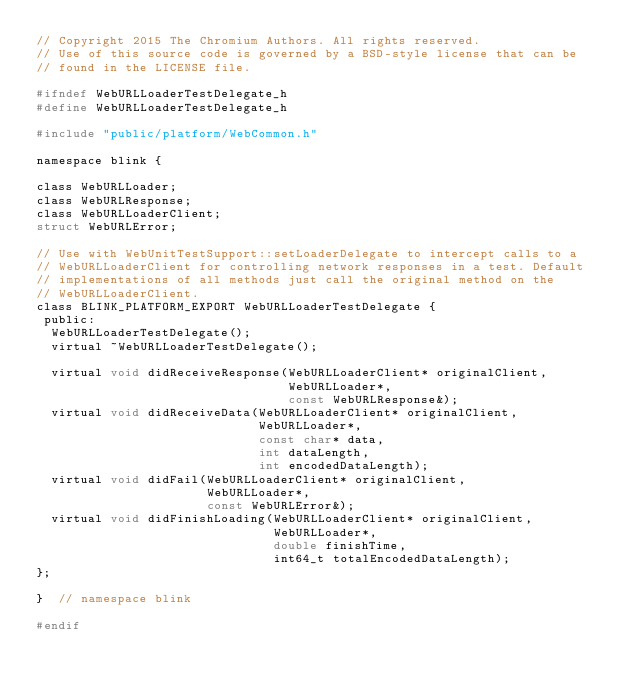Convert code to text. <code><loc_0><loc_0><loc_500><loc_500><_C_>// Copyright 2015 The Chromium Authors. All rights reserved.
// Use of this source code is governed by a BSD-style license that can be
// found in the LICENSE file.

#ifndef WebURLLoaderTestDelegate_h
#define WebURLLoaderTestDelegate_h

#include "public/platform/WebCommon.h"

namespace blink {

class WebURLLoader;
class WebURLResponse;
class WebURLLoaderClient;
struct WebURLError;

// Use with WebUnitTestSupport::setLoaderDelegate to intercept calls to a
// WebURLLoaderClient for controlling network responses in a test. Default
// implementations of all methods just call the original method on the
// WebURLLoaderClient.
class BLINK_PLATFORM_EXPORT WebURLLoaderTestDelegate {
 public:
  WebURLLoaderTestDelegate();
  virtual ~WebURLLoaderTestDelegate();

  virtual void didReceiveResponse(WebURLLoaderClient* originalClient,
                                  WebURLLoader*,
                                  const WebURLResponse&);
  virtual void didReceiveData(WebURLLoaderClient* originalClient,
                              WebURLLoader*,
                              const char* data,
                              int dataLength,
                              int encodedDataLength);
  virtual void didFail(WebURLLoaderClient* originalClient,
                       WebURLLoader*,
                       const WebURLError&);
  virtual void didFinishLoading(WebURLLoaderClient* originalClient,
                                WebURLLoader*,
                                double finishTime,
                                int64_t totalEncodedDataLength);
};

}  // namespace blink

#endif
</code> 